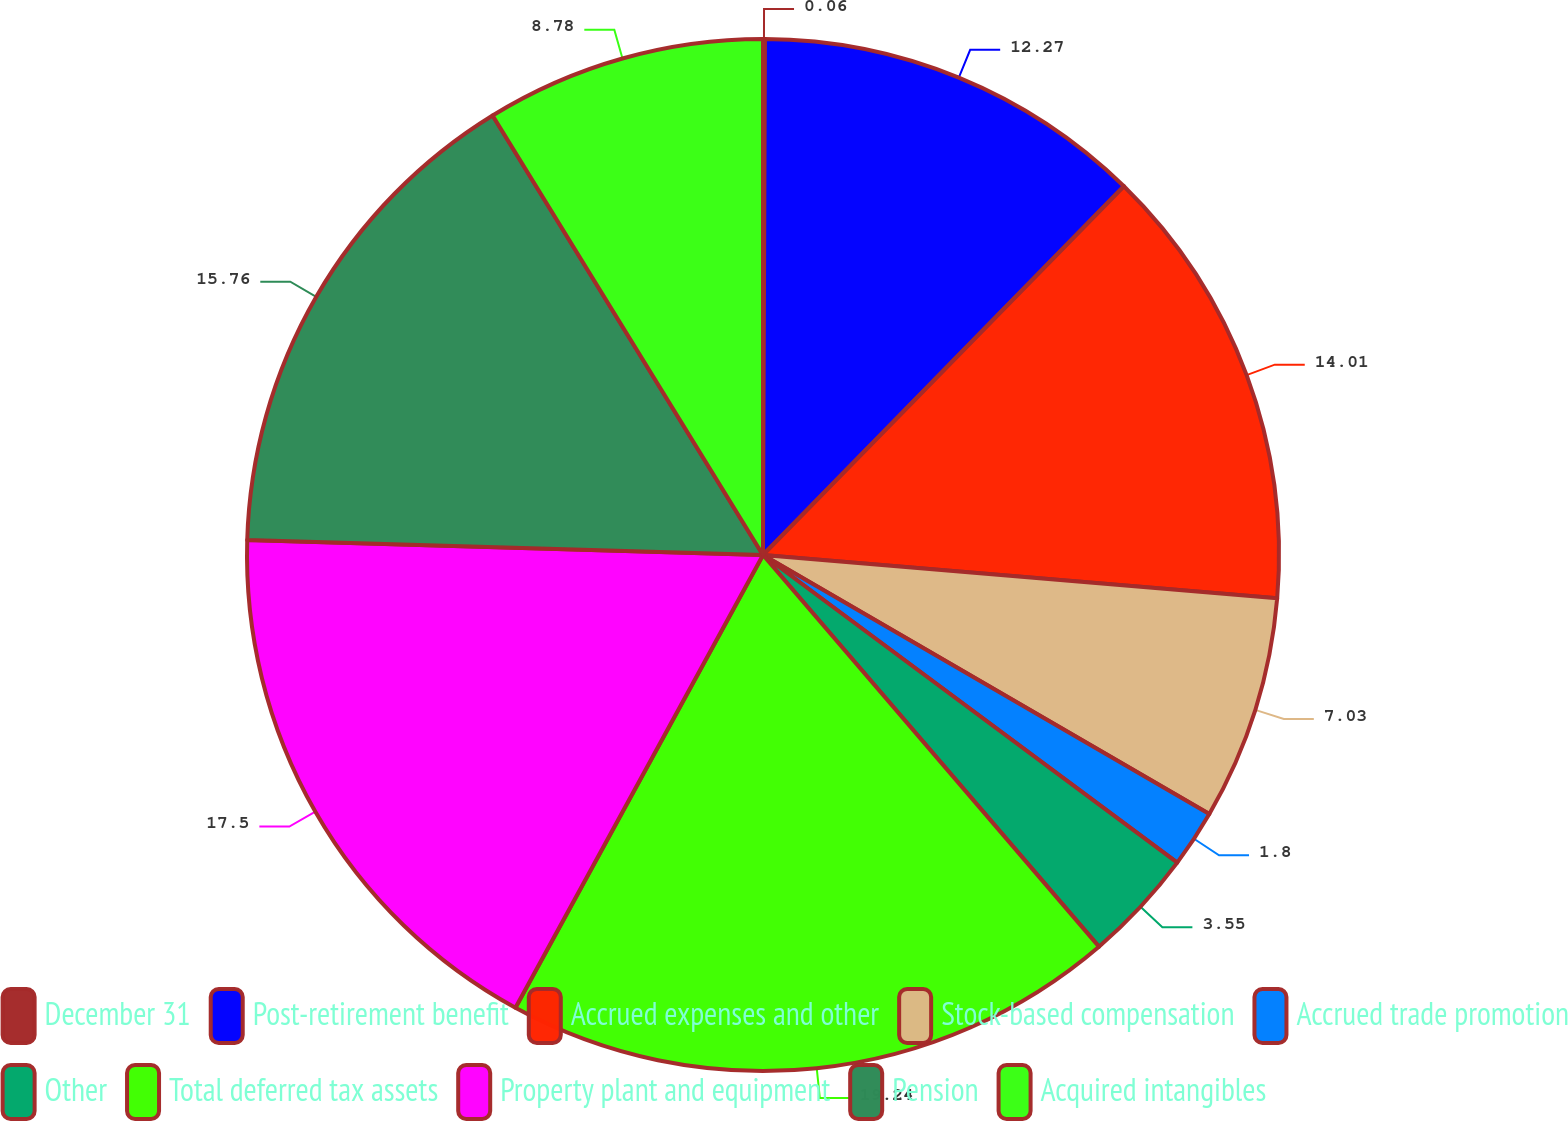<chart> <loc_0><loc_0><loc_500><loc_500><pie_chart><fcel>December 31<fcel>Post-retirement benefit<fcel>Accrued expenses and other<fcel>Stock-based compensation<fcel>Accrued trade promotion<fcel>Other<fcel>Total deferred tax assets<fcel>Property plant and equipment<fcel>Pension<fcel>Acquired intangibles<nl><fcel>0.06%<fcel>12.27%<fcel>14.01%<fcel>7.03%<fcel>1.8%<fcel>3.55%<fcel>19.25%<fcel>17.5%<fcel>15.76%<fcel>8.78%<nl></chart> 